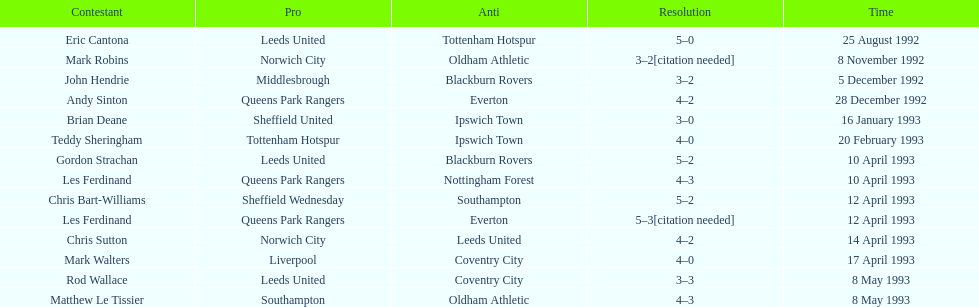In the 1992-1993 premier league, what was the total number of hat tricks scored by all players? 14. 